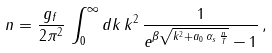Convert formula to latex. <formula><loc_0><loc_0><loc_500><loc_500>n = \frac { g _ { f } } { 2 \pi ^ { 2 } } \, \int _ { 0 } ^ { \infty } d k \, k ^ { 2 } \, \frac { 1 } { e ^ { \beta \sqrt { k ^ { 2 } + a _ { 0 } \, \alpha _ { s } \, \frac { n } { T } } } - 1 } \, ,</formula> 